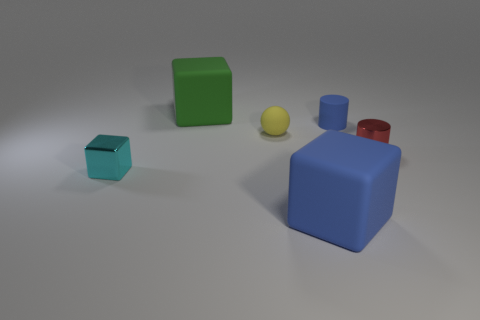Are there any other things that are the same material as the yellow object?
Your answer should be very brief. Yes. There is a small matte object that is on the right side of the tiny yellow object; is its shape the same as the metallic thing that is to the right of the metal block?
Offer a terse response. Yes. Is the number of cyan things that are on the left side of the small cyan metal object less than the number of tiny yellow spheres?
Offer a very short reply. Yes. What number of rubber balls have the same color as the small metallic cylinder?
Your answer should be very brief. 0. How big is the yellow thing in front of the small blue matte cylinder?
Provide a short and direct response. Small. There is a metallic object on the right side of the big object that is in front of the object that is to the left of the big green cube; what shape is it?
Your answer should be compact. Cylinder. The rubber object that is both behind the tiny metallic cylinder and in front of the tiny blue thing has what shape?
Your response must be concise. Sphere. Are there any cyan cylinders that have the same size as the cyan shiny thing?
Your answer should be compact. No. Does the metallic object that is behind the cyan shiny thing have the same shape as the tiny blue thing?
Offer a very short reply. Yes. Does the tiny cyan object have the same shape as the large blue object?
Your answer should be compact. Yes. 